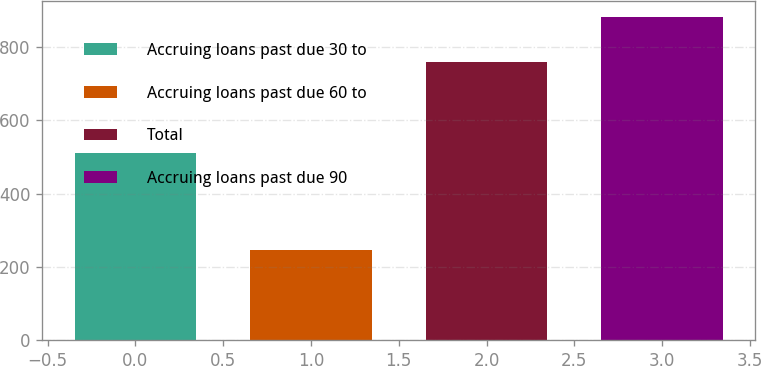Convert chart to OTSL. <chart><loc_0><loc_0><loc_500><loc_500><bar_chart><fcel>Accruing loans past due 30 to<fcel>Accruing loans past due 60 to<fcel>Total<fcel>Accruing loans past due 90<nl><fcel>511<fcel>248<fcel>759<fcel>881<nl></chart> 